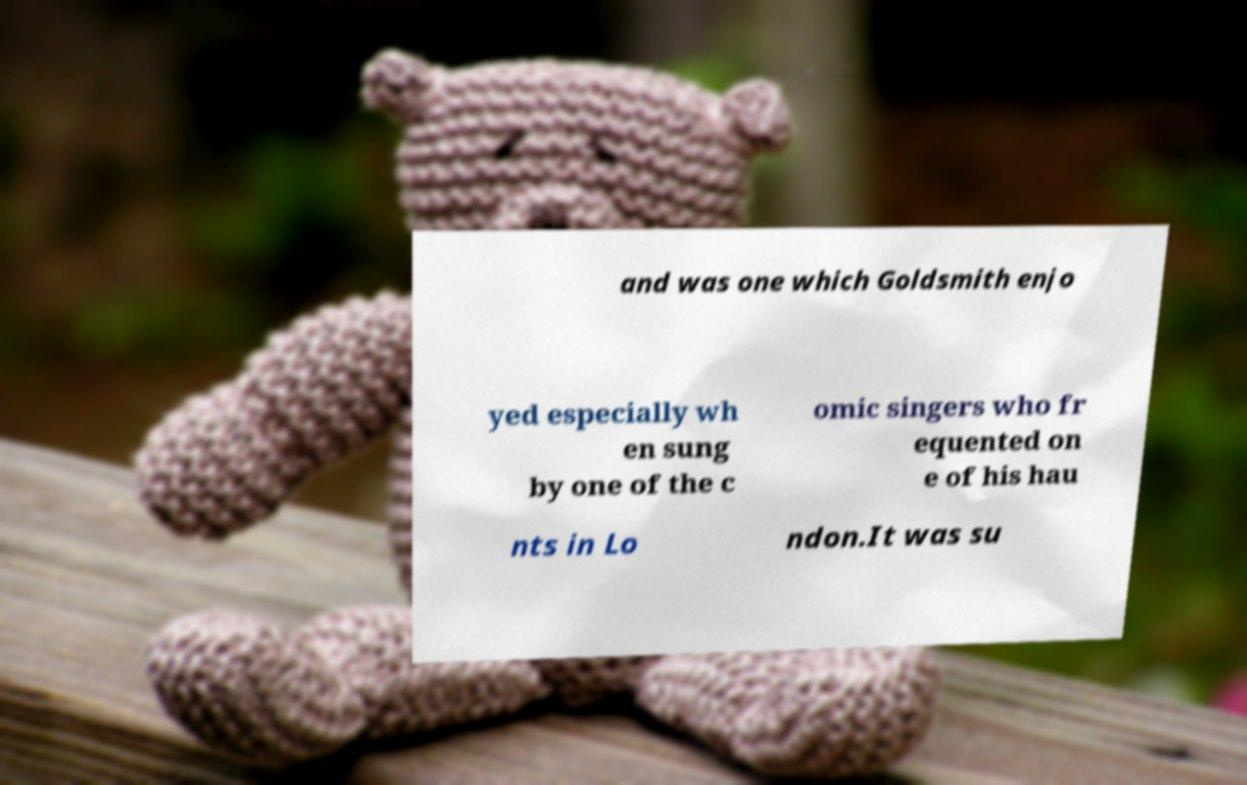For documentation purposes, I need the text within this image transcribed. Could you provide that? and was one which Goldsmith enjo yed especially wh en sung by one of the c omic singers who fr equented on e of his hau nts in Lo ndon.It was su 